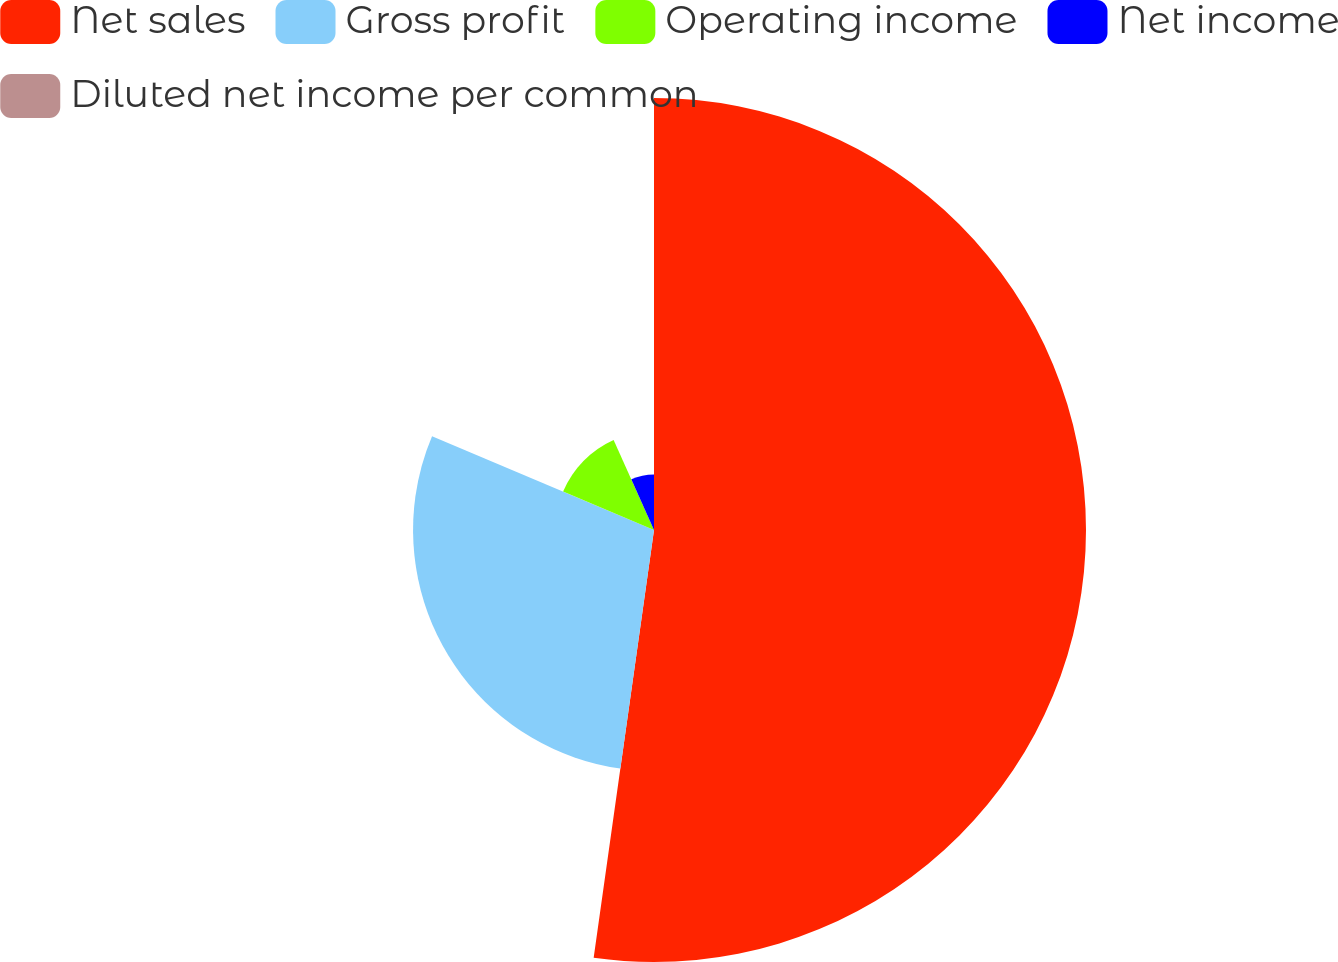Convert chart. <chart><loc_0><loc_0><loc_500><loc_500><pie_chart><fcel>Net sales<fcel>Gross profit<fcel>Operating income<fcel>Net income<fcel>Diluted net income per common<nl><fcel>52.23%<fcel>29.13%<fcel>11.93%<fcel>6.71%<fcel>0.0%<nl></chart> 